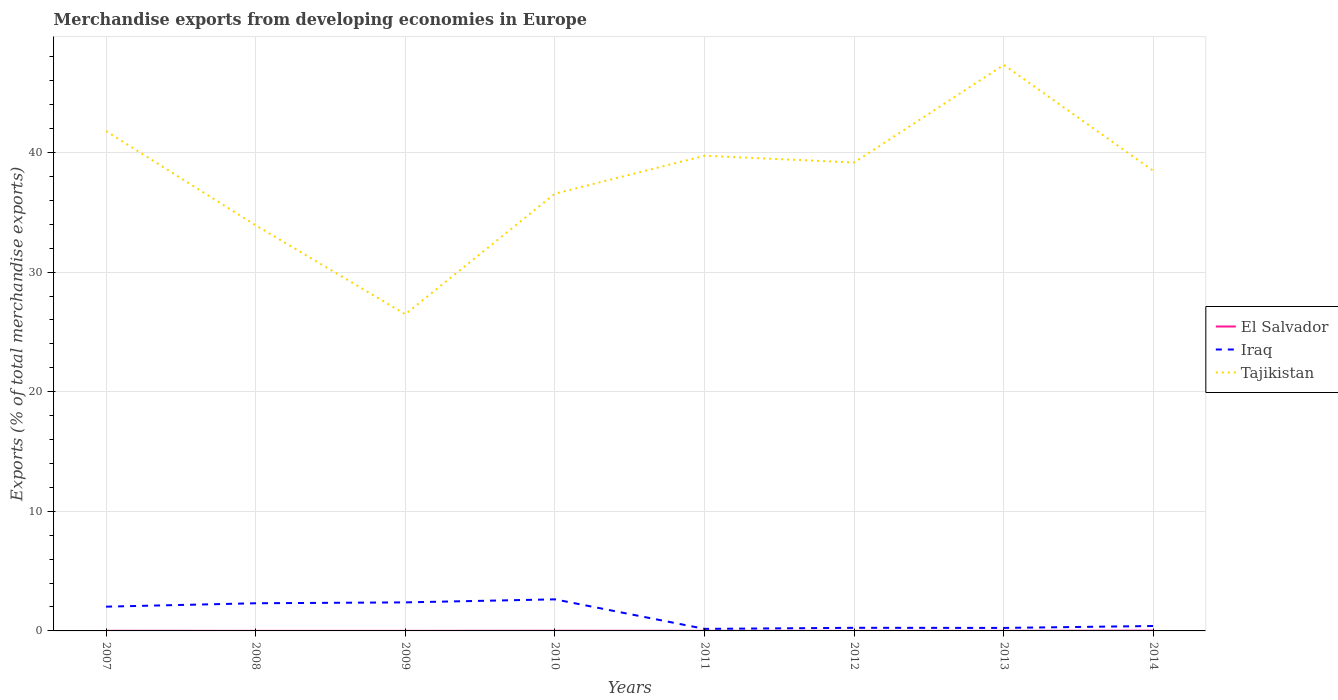How many different coloured lines are there?
Offer a very short reply. 3. Does the line corresponding to El Salvador intersect with the line corresponding to Iraq?
Make the answer very short. No. Is the number of lines equal to the number of legend labels?
Offer a very short reply. Yes. Across all years, what is the maximum percentage of total merchandise exports in Tajikistan?
Your response must be concise. 26.48. In which year was the percentage of total merchandise exports in El Salvador maximum?
Offer a terse response. 2012. What is the total percentage of total merchandise exports in Iraq in the graph?
Ensure brevity in your answer.  -0.07. What is the difference between the highest and the second highest percentage of total merchandise exports in Tajikistan?
Make the answer very short. 20.85. How many lines are there?
Keep it short and to the point. 3. How many years are there in the graph?
Your answer should be compact. 8. Are the values on the major ticks of Y-axis written in scientific E-notation?
Offer a very short reply. No. Does the graph contain grids?
Your response must be concise. Yes. What is the title of the graph?
Ensure brevity in your answer.  Merchandise exports from developing economies in Europe. What is the label or title of the Y-axis?
Your answer should be compact. Exports (% of total merchandise exports). What is the Exports (% of total merchandise exports) of El Salvador in 2007?
Your answer should be very brief. 0.01. What is the Exports (% of total merchandise exports) in Iraq in 2007?
Provide a succinct answer. 2.03. What is the Exports (% of total merchandise exports) in Tajikistan in 2007?
Your answer should be very brief. 41.79. What is the Exports (% of total merchandise exports) in El Salvador in 2008?
Offer a terse response. 0. What is the Exports (% of total merchandise exports) of Iraq in 2008?
Ensure brevity in your answer.  2.31. What is the Exports (% of total merchandise exports) of Tajikistan in 2008?
Your answer should be compact. 33.91. What is the Exports (% of total merchandise exports) of El Salvador in 2009?
Ensure brevity in your answer.  0. What is the Exports (% of total merchandise exports) in Iraq in 2009?
Offer a very short reply. 2.39. What is the Exports (% of total merchandise exports) in Tajikistan in 2009?
Keep it short and to the point. 26.48. What is the Exports (% of total merchandise exports) in El Salvador in 2010?
Your answer should be very brief. 0.01. What is the Exports (% of total merchandise exports) in Iraq in 2010?
Provide a short and direct response. 2.64. What is the Exports (% of total merchandise exports) in Tajikistan in 2010?
Offer a very short reply. 36.56. What is the Exports (% of total merchandise exports) in El Salvador in 2011?
Your answer should be compact. 0.01. What is the Exports (% of total merchandise exports) in Iraq in 2011?
Your response must be concise. 0.17. What is the Exports (% of total merchandise exports) of Tajikistan in 2011?
Ensure brevity in your answer.  39.73. What is the Exports (% of total merchandise exports) in El Salvador in 2012?
Offer a terse response. 0. What is the Exports (% of total merchandise exports) in Iraq in 2012?
Ensure brevity in your answer.  0.26. What is the Exports (% of total merchandise exports) in Tajikistan in 2012?
Provide a short and direct response. 39.16. What is the Exports (% of total merchandise exports) in El Salvador in 2013?
Offer a very short reply. 0. What is the Exports (% of total merchandise exports) in Iraq in 2013?
Keep it short and to the point. 0.25. What is the Exports (% of total merchandise exports) in Tajikistan in 2013?
Offer a terse response. 47.32. What is the Exports (% of total merchandise exports) of El Salvador in 2014?
Provide a succinct answer. 0.02. What is the Exports (% of total merchandise exports) in Iraq in 2014?
Make the answer very short. 0.41. What is the Exports (% of total merchandise exports) in Tajikistan in 2014?
Keep it short and to the point. 38.46. Across all years, what is the maximum Exports (% of total merchandise exports) in El Salvador?
Offer a terse response. 0.02. Across all years, what is the maximum Exports (% of total merchandise exports) in Iraq?
Provide a short and direct response. 2.64. Across all years, what is the maximum Exports (% of total merchandise exports) in Tajikistan?
Your answer should be compact. 47.32. Across all years, what is the minimum Exports (% of total merchandise exports) of El Salvador?
Offer a terse response. 0. Across all years, what is the minimum Exports (% of total merchandise exports) of Iraq?
Your answer should be compact. 0.17. Across all years, what is the minimum Exports (% of total merchandise exports) in Tajikistan?
Ensure brevity in your answer.  26.48. What is the total Exports (% of total merchandise exports) of El Salvador in the graph?
Provide a short and direct response. 0.07. What is the total Exports (% of total merchandise exports) of Iraq in the graph?
Ensure brevity in your answer.  10.46. What is the total Exports (% of total merchandise exports) of Tajikistan in the graph?
Provide a succinct answer. 303.41. What is the difference between the Exports (% of total merchandise exports) of El Salvador in 2007 and that in 2008?
Keep it short and to the point. 0. What is the difference between the Exports (% of total merchandise exports) in Iraq in 2007 and that in 2008?
Offer a terse response. -0.28. What is the difference between the Exports (% of total merchandise exports) of Tajikistan in 2007 and that in 2008?
Your response must be concise. 7.88. What is the difference between the Exports (% of total merchandise exports) in El Salvador in 2007 and that in 2009?
Your answer should be compact. 0. What is the difference between the Exports (% of total merchandise exports) of Iraq in 2007 and that in 2009?
Ensure brevity in your answer.  -0.36. What is the difference between the Exports (% of total merchandise exports) in Tajikistan in 2007 and that in 2009?
Provide a succinct answer. 15.31. What is the difference between the Exports (% of total merchandise exports) of El Salvador in 2007 and that in 2010?
Your answer should be very brief. -0. What is the difference between the Exports (% of total merchandise exports) of Iraq in 2007 and that in 2010?
Ensure brevity in your answer.  -0.61. What is the difference between the Exports (% of total merchandise exports) in Tajikistan in 2007 and that in 2010?
Your answer should be very brief. 5.23. What is the difference between the Exports (% of total merchandise exports) in El Salvador in 2007 and that in 2011?
Offer a terse response. 0. What is the difference between the Exports (% of total merchandise exports) in Iraq in 2007 and that in 2011?
Your answer should be very brief. 1.86. What is the difference between the Exports (% of total merchandise exports) in Tajikistan in 2007 and that in 2011?
Offer a terse response. 2.06. What is the difference between the Exports (% of total merchandise exports) of El Salvador in 2007 and that in 2012?
Your answer should be very brief. 0.01. What is the difference between the Exports (% of total merchandise exports) of Iraq in 2007 and that in 2012?
Provide a short and direct response. 1.77. What is the difference between the Exports (% of total merchandise exports) of Tajikistan in 2007 and that in 2012?
Ensure brevity in your answer.  2.63. What is the difference between the Exports (% of total merchandise exports) in El Salvador in 2007 and that in 2013?
Provide a succinct answer. 0. What is the difference between the Exports (% of total merchandise exports) of Iraq in 2007 and that in 2013?
Provide a short and direct response. 1.78. What is the difference between the Exports (% of total merchandise exports) in Tajikistan in 2007 and that in 2013?
Offer a very short reply. -5.54. What is the difference between the Exports (% of total merchandise exports) of El Salvador in 2007 and that in 2014?
Offer a terse response. -0.01. What is the difference between the Exports (% of total merchandise exports) in Iraq in 2007 and that in 2014?
Ensure brevity in your answer.  1.62. What is the difference between the Exports (% of total merchandise exports) of Tajikistan in 2007 and that in 2014?
Keep it short and to the point. 3.33. What is the difference between the Exports (% of total merchandise exports) of El Salvador in 2008 and that in 2009?
Your response must be concise. 0. What is the difference between the Exports (% of total merchandise exports) of Iraq in 2008 and that in 2009?
Offer a very short reply. -0.07. What is the difference between the Exports (% of total merchandise exports) in Tajikistan in 2008 and that in 2009?
Offer a terse response. 7.44. What is the difference between the Exports (% of total merchandise exports) of El Salvador in 2008 and that in 2010?
Keep it short and to the point. -0.01. What is the difference between the Exports (% of total merchandise exports) of Iraq in 2008 and that in 2010?
Ensure brevity in your answer.  -0.33. What is the difference between the Exports (% of total merchandise exports) of Tajikistan in 2008 and that in 2010?
Your answer should be compact. -2.64. What is the difference between the Exports (% of total merchandise exports) in El Salvador in 2008 and that in 2011?
Offer a terse response. -0. What is the difference between the Exports (% of total merchandise exports) in Iraq in 2008 and that in 2011?
Your response must be concise. 2.14. What is the difference between the Exports (% of total merchandise exports) of Tajikistan in 2008 and that in 2011?
Offer a terse response. -5.82. What is the difference between the Exports (% of total merchandise exports) in El Salvador in 2008 and that in 2012?
Provide a succinct answer. 0. What is the difference between the Exports (% of total merchandise exports) of Iraq in 2008 and that in 2012?
Give a very brief answer. 2.05. What is the difference between the Exports (% of total merchandise exports) of Tajikistan in 2008 and that in 2012?
Provide a succinct answer. -5.25. What is the difference between the Exports (% of total merchandise exports) in El Salvador in 2008 and that in 2013?
Provide a short and direct response. 0. What is the difference between the Exports (% of total merchandise exports) of Iraq in 2008 and that in 2013?
Your answer should be compact. 2.06. What is the difference between the Exports (% of total merchandise exports) of Tajikistan in 2008 and that in 2013?
Offer a terse response. -13.41. What is the difference between the Exports (% of total merchandise exports) of El Salvador in 2008 and that in 2014?
Offer a terse response. -0.02. What is the difference between the Exports (% of total merchandise exports) in Iraq in 2008 and that in 2014?
Your response must be concise. 1.9. What is the difference between the Exports (% of total merchandise exports) of Tajikistan in 2008 and that in 2014?
Offer a terse response. -4.55. What is the difference between the Exports (% of total merchandise exports) in El Salvador in 2009 and that in 2010?
Offer a terse response. -0.01. What is the difference between the Exports (% of total merchandise exports) in Iraq in 2009 and that in 2010?
Your answer should be compact. -0.25. What is the difference between the Exports (% of total merchandise exports) of Tajikistan in 2009 and that in 2010?
Your response must be concise. -10.08. What is the difference between the Exports (% of total merchandise exports) of El Salvador in 2009 and that in 2011?
Make the answer very short. -0. What is the difference between the Exports (% of total merchandise exports) in Iraq in 2009 and that in 2011?
Your response must be concise. 2.22. What is the difference between the Exports (% of total merchandise exports) of Tajikistan in 2009 and that in 2011?
Your answer should be compact. -13.25. What is the difference between the Exports (% of total merchandise exports) of El Salvador in 2009 and that in 2012?
Give a very brief answer. 0. What is the difference between the Exports (% of total merchandise exports) in Iraq in 2009 and that in 2012?
Keep it short and to the point. 2.13. What is the difference between the Exports (% of total merchandise exports) in Tajikistan in 2009 and that in 2012?
Ensure brevity in your answer.  -12.69. What is the difference between the Exports (% of total merchandise exports) in Iraq in 2009 and that in 2013?
Your answer should be very brief. 2.13. What is the difference between the Exports (% of total merchandise exports) in Tajikistan in 2009 and that in 2013?
Ensure brevity in your answer.  -20.85. What is the difference between the Exports (% of total merchandise exports) in El Salvador in 2009 and that in 2014?
Ensure brevity in your answer.  -0.02. What is the difference between the Exports (% of total merchandise exports) in Iraq in 2009 and that in 2014?
Keep it short and to the point. 1.97. What is the difference between the Exports (% of total merchandise exports) of Tajikistan in 2009 and that in 2014?
Your answer should be very brief. -11.98. What is the difference between the Exports (% of total merchandise exports) in El Salvador in 2010 and that in 2011?
Your answer should be very brief. 0. What is the difference between the Exports (% of total merchandise exports) of Iraq in 2010 and that in 2011?
Ensure brevity in your answer.  2.47. What is the difference between the Exports (% of total merchandise exports) of Tajikistan in 2010 and that in 2011?
Provide a short and direct response. -3.17. What is the difference between the Exports (% of total merchandise exports) of El Salvador in 2010 and that in 2012?
Offer a very short reply. 0.01. What is the difference between the Exports (% of total merchandise exports) of Iraq in 2010 and that in 2012?
Your answer should be compact. 2.38. What is the difference between the Exports (% of total merchandise exports) in Tajikistan in 2010 and that in 2012?
Ensure brevity in your answer.  -2.61. What is the difference between the Exports (% of total merchandise exports) of El Salvador in 2010 and that in 2013?
Your answer should be very brief. 0.01. What is the difference between the Exports (% of total merchandise exports) of Iraq in 2010 and that in 2013?
Your answer should be very brief. 2.39. What is the difference between the Exports (% of total merchandise exports) in Tajikistan in 2010 and that in 2013?
Keep it short and to the point. -10.77. What is the difference between the Exports (% of total merchandise exports) in El Salvador in 2010 and that in 2014?
Provide a short and direct response. -0.01. What is the difference between the Exports (% of total merchandise exports) of Iraq in 2010 and that in 2014?
Ensure brevity in your answer.  2.23. What is the difference between the Exports (% of total merchandise exports) of Tajikistan in 2010 and that in 2014?
Offer a terse response. -1.9. What is the difference between the Exports (% of total merchandise exports) in El Salvador in 2011 and that in 2012?
Provide a succinct answer. 0. What is the difference between the Exports (% of total merchandise exports) of Iraq in 2011 and that in 2012?
Your response must be concise. -0.09. What is the difference between the Exports (% of total merchandise exports) in Tajikistan in 2011 and that in 2012?
Make the answer very short. 0.56. What is the difference between the Exports (% of total merchandise exports) in El Salvador in 2011 and that in 2013?
Provide a short and direct response. 0. What is the difference between the Exports (% of total merchandise exports) in Iraq in 2011 and that in 2013?
Offer a terse response. -0.08. What is the difference between the Exports (% of total merchandise exports) in Tajikistan in 2011 and that in 2013?
Ensure brevity in your answer.  -7.6. What is the difference between the Exports (% of total merchandise exports) of El Salvador in 2011 and that in 2014?
Offer a terse response. -0.02. What is the difference between the Exports (% of total merchandise exports) of Iraq in 2011 and that in 2014?
Your answer should be very brief. -0.24. What is the difference between the Exports (% of total merchandise exports) in Tajikistan in 2011 and that in 2014?
Ensure brevity in your answer.  1.27. What is the difference between the Exports (% of total merchandise exports) of El Salvador in 2012 and that in 2013?
Provide a short and direct response. -0. What is the difference between the Exports (% of total merchandise exports) in Iraq in 2012 and that in 2013?
Offer a very short reply. 0.01. What is the difference between the Exports (% of total merchandise exports) of Tajikistan in 2012 and that in 2013?
Your response must be concise. -8.16. What is the difference between the Exports (% of total merchandise exports) in El Salvador in 2012 and that in 2014?
Give a very brief answer. -0.02. What is the difference between the Exports (% of total merchandise exports) of Iraq in 2012 and that in 2014?
Provide a succinct answer. -0.15. What is the difference between the Exports (% of total merchandise exports) in Tajikistan in 2012 and that in 2014?
Offer a terse response. 0.7. What is the difference between the Exports (% of total merchandise exports) of El Salvador in 2013 and that in 2014?
Provide a short and direct response. -0.02. What is the difference between the Exports (% of total merchandise exports) of Iraq in 2013 and that in 2014?
Ensure brevity in your answer.  -0.16. What is the difference between the Exports (% of total merchandise exports) of Tajikistan in 2013 and that in 2014?
Your response must be concise. 8.87. What is the difference between the Exports (% of total merchandise exports) in El Salvador in 2007 and the Exports (% of total merchandise exports) in Iraq in 2008?
Provide a short and direct response. -2.3. What is the difference between the Exports (% of total merchandise exports) in El Salvador in 2007 and the Exports (% of total merchandise exports) in Tajikistan in 2008?
Make the answer very short. -33.9. What is the difference between the Exports (% of total merchandise exports) of Iraq in 2007 and the Exports (% of total merchandise exports) of Tajikistan in 2008?
Your answer should be very brief. -31.88. What is the difference between the Exports (% of total merchandise exports) of El Salvador in 2007 and the Exports (% of total merchandise exports) of Iraq in 2009?
Provide a succinct answer. -2.38. What is the difference between the Exports (% of total merchandise exports) in El Salvador in 2007 and the Exports (% of total merchandise exports) in Tajikistan in 2009?
Your answer should be compact. -26.47. What is the difference between the Exports (% of total merchandise exports) of Iraq in 2007 and the Exports (% of total merchandise exports) of Tajikistan in 2009?
Keep it short and to the point. -24.45. What is the difference between the Exports (% of total merchandise exports) of El Salvador in 2007 and the Exports (% of total merchandise exports) of Iraq in 2010?
Offer a terse response. -2.63. What is the difference between the Exports (% of total merchandise exports) in El Salvador in 2007 and the Exports (% of total merchandise exports) in Tajikistan in 2010?
Ensure brevity in your answer.  -36.55. What is the difference between the Exports (% of total merchandise exports) of Iraq in 2007 and the Exports (% of total merchandise exports) of Tajikistan in 2010?
Provide a short and direct response. -34.53. What is the difference between the Exports (% of total merchandise exports) in El Salvador in 2007 and the Exports (% of total merchandise exports) in Iraq in 2011?
Your answer should be very brief. -0.16. What is the difference between the Exports (% of total merchandise exports) in El Salvador in 2007 and the Exports (% of total merchandise exports) in Tajikistan in 2011?
Ensure brevity in your answer.  -39.72. What is the difference between the Exports (% of total merchandise exports) in Iraq in 2007 and the Exports (% of total merchandise exports) in Tajikistan in 2011?
Your answer should be very brief. -37.7. What is the difference between the Exports (% of total merchandise exports) in El Salvador in 2007 and the Exports (% of total merchandise exports) in Iraq in 2012?
Ensure brevity in your answer.  -0.25. What is the difference between the Exports (% of total merchandise exports) in El Salvador in 2007 and the Exports (% of total merchandise exports) in Tajikistan in 2012?
Offer a very short reply. -39.15. What is the difference between the Exports (% of total merchandise exports) in Iraq in 2007 and the Exports (% of total merchandise exports) in Tajikistan in 2012?
Provide a short and direct response. -37.14. What is the difference between the Exports (% of total merchandise exports) in El Salvador in 2007 and the Exports (% of total merchandise exports) in Iraq in 2013?
Give a very brief answer. -0.24. What is the difference between the Exports (% of total merchandise exports) of El Salvador in 2007 and the Exports (% of total merchandise exports) of Tajikistan in 2013?
Keep it short and to the point. -47.32. What is the difference between the Exports (% of total merchandise exports) in Iraq in 2007 and the Exports (% of total merchandise exports) in Tajikistan in 2013?
Provide a short and direct response. -45.3. What is the difference between the Exports (% of total merchandise exports) of El Salvador in 2007 and the Exports (% of total merchandise exports) of Iraq in 2014?
Give a very brief answer. -0.4. What is the difference between the Exports (% of total merchandise exports) in El Salvador in 2007 and the Exports (% of total merchandise exports) in Tajikistan in 2014?
Provide a short and direct response. -38.45. What is the difference between the Exports (% of total merchandise exports) in Iraq in 2007 and the Exports (% of total merchandise exports) in Tajikistan in 2014?
Your response must be concise. -36.43. What is the difference between the Exports (% of total merchandise exports) of El Salvador in 2008 and the Exports (% of total merchandise exports) of Iraq in 2009?
Offer a very short reply. -2.38. What is the difference between the Exports (% of total merchandise exports) in El Salvador in 2008 and the Exports (% of total merchandise exports) in Tajikistan in 2009?
Offer a terse response. -26.47. What is the difference between the Exports (% of total merchandise exports) of Iraq in 2008 and the Exports (% of total merchandise exports) of Tajikistan in 2009?
Provide a succinct answer. -24.16. What is the difference between the Exports (% of total merchandise exports) of El Salvador in 2008 and the Exports (% of total merchandise exports) of Iraq in 2010?
Make the answer very short. -2.64. What is the difference between the Exports (% of total merchandise exports) of El Salvador in 2008 and the Exports (% of total merchandise exports) of Tajikistan in 2010?
Offer a terse response. -36.55. What is the difference between the Exports (% of total merchandise exports) in Iraq in 2008 and the Exports (% of total merchandise exports) in Tajikistan in 2010?
Provide a short and direct response. -34.24. What is the difference between the Exports (% of total merchandise exports) in El Salvador in 2008 and the Exports (% of total merchandise exports) in Iraq in 2011?
Provide a short and direct response. -0.17. What is the difference between the Exports (% of total merchandise exports) in El Salvador in 2008 and the Exports (% of total merchandise exports) in Tajikistan in 2011?
Provide a succinct answer. -39.72. What is the difference between the Exports (% of total merchandise exports) in Iraq in 2008 and the Exports (% of total merchandise exports) in Tajikistan in 2011?
Ensure brevity in your answer.  -37.41. What is the difference between the Exports (% of total merchandise exports) of El Salvador in 2008 and the Exports (% of total merchandise exports) of Iraq in 2012?
Your answer should be very brief. -0.26. What is the difference between the Exports (% of total merchandise exports) of El Salvador in 2008 and the Exports (% of total merchandise exports) of Tajikistan in 2012?
Provide a short and direct response. -39.16. What is the difference between the Exports (% of total merchandise exports) of Iraq in 2008 and the Exports (% of total merchandise exports) of Tajikistan in 2012?
Provide a short and direct response. -36.85. What is the difference between the Exports (% of total merchandise exports) in El Salvador in 2008 and the Exports (% of total merchandise exports) in Iraq in 2013?
Your response must be concise. -0.25. What is the difference between the Exports (% of total merchandise exports) of El Salvador in 2008 and the Exports (% of total merchandise exports) of Tajikistan in 2013?
Provide a short and direct response. -47.32. What is the difference between the Exports (% of total merchandise exports) of Iraq in 2008 and the Exports (% of total merchandise exports) of Tajikistan in 2013?
Your answer should be compact. -45.01. What is the difference between the Exports (% of total merchandise exports) of El Salvador in 2008 and the Exports (% of total merchandise exports) of Iraq in 2014?
Offer a very short reply. -0.41. What is the difference between the Exports (% of total merchandise exports) in El Salvador in 2008 and the Exports (% of total merchandise exports) in Tajikistan in 2014?
Your response must be concise. -38.45. What is the difference between the Exports (% of total merchandise exports) of Iraq in 2008 and the Exports (% of total merchandise exports) of Tajikistan in 2014?
Give a very brief answer. -36.15. What is the difference between the Exports (% of total merchandise exports) of El Salvador in 2009 and the Exports (% of total merchandise exports) of Iraq in 2010?
Offer a very short reply. -2.64. What is the difference between the Exports (% of total merchandise exports) in El Salvador in 2009 and the Exports (% of total merchandise exports) in Tajikistan in 2010?
Ensure brevity in your answer.  -36.55. What is the difference between the Exports (% of total merchandise exports) of Iraq in 2009 and the Exports (% of total merchandise exports) of Tajikistan in 2010?
Offer a terse response. -34.17. What is the difference between the Exports (% of total merchandise exports) in El Salvador in 2009 and the Exports (% of total merchandise exports) in Iraq in 2011?
Keep it short and to the point. -0.17. What is the difference between the Exports (% of total merchandise exports) of El Salvador in 2009 and the Exports (% of total merchandise exports) of Tajikistan in 2011?
Give a very brief answer. -39.72. What is the difference between the Exports (% of total merchandise exports) in Iraq in 2009 and the Exports (% of total merchandise exports) in Tajikistan in 2011?
Keep it short and to the point. -37.34. What is the difference between the Exports (% of total merchandise exports) of El Salvador in 2009 and the Exports (% of total merchandise exports) of Iraq in 2012?
Your response must be concise. -0.26. What is the difference between the Exports (% of total merchandise exports) of El Salvador in 2009 and the Exports (% of total merchandise exports) of Tajikistan in 2012?
Offer a very short reply. -39.16. What is the difference between the Exports (% of total merchandise exports) in Iraq in 2009 and the Exports (% of total merchandise exports) in Tajikistan in 2012?
Your answer should be compact. -36.78. What is the difference between the Exports (% of total merchandise exports) of El Salvador in 2009 and the Exports (% of total merchandise exports) of Iraq in 2013?
Offer a terse response. -0.25. What is the difference between the Exports (% of total merchandise exports) in El Salvador in 2009 and the Exports (% of total merchandise exports) in Tajikistan in 2013?
Ensure brevity in your answer.  -47.32. What is the difference between the Exports (% of total merchandise exports) in Iraq in 2009 and the Exports (% of total merchandise exports) in Tajikistan in 2013?
Keep it short and to the point. -44.94. What is the difference between the Exports (% of total merchandise exports) in El Salvador in 2009 and the Exports (% of total merchandise exports) in Iraq in 2014?
Your response must be concise. -0.41. What is the difference between the Exports (% of total merchandise exports) of El Salvador in 2009 and the Exports (% of total merchandise exports) of Tajikistan in 2014?
Provide a short and direct response. -38.45. What is the difference between the Exports (% of total merchandise exports) of Iraq in 2009 and the Exports (% of total merchandise exports) of Tajikistan in 2014?
Ensure brevity in your answer.  -36.07. What is the difference between the Exports (% of total merchandise exports) in El Salvador in 2010 and the Exports (% of total merchandise exports) in Iraq in 2011?
Your answer should be very brief. -0.16. What is the difference between the Exports (% of total merchandise exports) of El Salvador in 2010 and the Exports (% of total merchandise exports) of Tajikistan in 2011?
Ensure brevity in your answer.  -39.72. What is the difference between the Exports (% of total merchandise exports) in Iraq in 2010 and the Exports (% of total merchandise exports) in Tajikistan in 2011?
Your answer should be compact. -37.09. What is the difference between the Exports (% of total merchandise exports) of El Salvador in 2010 and the Exports (% of total merchandise exports) of Iraq in 2012?
Make the answer very short. -0.25. What is the difference between the Exports (% of total merchandise exports) of El Salvador in 2010 and the Exports (% of total merchandise exports) of Tajikistan in 2012?
Keep it short and to the point. -39.15. What is the difference between the Exports (% of total merchandise exports) in Iraq in 2010 and the Exports (% of total merchandise exports) in Tajikistan in 2012?
Give a very brief answer. -36.52. What is the difference between the Exports (% of total merchandise exports) in El Salvador in 2010 and the Exports (% of total merchandise exports) in Iraq in 2013?
Offer a terse response. -0.24. What is the difference between the Exports (% of total merchandise exports) of El Salvador in 2010 and the Exports (% of total merchandise exports) of Tajikistan in 2013?
Offer a terse response. -47.31. What is the difference between the Exports (% of total merchandise exports) of Iraq in 2010 and the Exports (% of total merchandise exports) of Tajikistan in 2013?
Keep it short and to the point. -44.68. What is the difference between the Exports (% of total merchandise exports) of El Salvador in 2010 and the Exports (% of total merchandise exports) of Iraq in 2014?
Offer a very short reply. -0.4. What is the difference between the Exports (% of total merchandise exports) of El Salvador in 2010 and the Exports (% of total merchandise exports) of Tajikistan in 2014?
Your response must be concise. -38.45. What is the difference between the Exports (% of total merchandise exports) of Iraq in 2010 and the Exports (% of total merchandise exports) of Tajikistan in 2014?
Offer a very short reply. -35.82. What is the difference between the Exports (% of total merchandise exports) of El Salvador in 2011 and the Exports (% of total merchandise exports) of Iraq in 2012?
Your response must be concise. -0.25. What is the difference between the Exports (% of total merchandise exports) of El Salvador in 2011 and the Exports (% of total merchandise exports) of Tajikistan in 2012?
Ensure brevity in your answer.  -39.16. What is the difference between the Exports (% of total merchandise exports) of Iraq in 2011 and the Exports (% of total merchandise exports) of Tajikistan in 2012?
Your answer should be compact. -38.99. What is the difference between the Exports (% of total merchandise exports) of El Salvador in 2011 and the Exports (% of total merchandise exports) of Iraq in 2013?
Provide a short and direct response. -0.25. What is the difference between the Exports (% of total merchandise exports) of El Salvador in 2011 and the Exports (% of total merchandise exports) of Tajikistan in 2013?
Offer a terse response. -47.32. What is the difference between the Exports (% of total merchandise exports) in Iraq in 2011 and the Exports (% of total merchandise exports) in Tajikistan in 2013?
Offer a terse response. -47.15. What is the difference between the Exports (% of total merchandise exports) of El Salvador in 2011 and the Exports (% of total merchandise exports) of Iraq in 2014?
Provide a short and direct response. -0.41. What is the difference between the Exports (% of total merchandise exports) in El Salvador in 2011 and the Exports (% of total merchandise exports) in Tajikistan in 2014?
Your response must be concise. -38.45. What is the difference between the Exports (% of total merchandise exports) of Iraq in 2011 and the Exports (% of total merchandise exports) of Tajikistan in 2014?
Make the answer very short. -38.29. What is the difference between the Exports (% of total merchandise exports) of El Salvador in 2012 and the Exports (% of total merchandise exports) of Iraq in 2013?
Your answer should be compact. -0.25. What is the difference between the Exports (% of total merchandise exports) of El Salvador in 2012 and the Exports (% of total merchandise exports) of Tajikistan in 2013?
Provide a succinct answer. -47.32. What is the difference between the Exports (% of total merchandise exports) in Iraq in 2012 and the Exports (% of total merchandise exports) in Tajikistan in 2013?
Give a very brief answer. -47.06. What is the difference between the Exports (% of total merchandise exports) in El Salvador in 2012 and the Exports (% of total merchandise exports) in Iraq in 2014?
Offer a terse response. -0.41. What is the difference between the Exports (% of total merchandise exports) in El Salvador in 2012 and the Exports (% of total merchandise exports) in Tajikistan in 2014?
Your answer should be very brief. -38.46. What is the difference between the Exports (% of total merchandise exports) of Iraq in 2012 and the Exports (% of total merchandise exports) of Tajikistan in 2014?
Offer a very short reply. -38.2. What is the difference between the Exports (% of total merchandise exports) in El Salvador in 2013 and the Exports (% of total merchandise exports) in Iraq in 2014?
Make the answer very short. -0.41. What is the difference between the Exports (% of total merchandise exports) of El Salvador in 2013 and the Exports (% of total merchandise exports) of Tajikistan in 2014?
Your response must be concise. -38.46. What is the difference between the Exports (% of total merchandise exports) of Iraq in 2013 and the Exports (% of total merchandise exports) of Tajikistan in 2014?
Give a very brief answer. -38.21. What is the average Exports (% of total merchandise exports) of El Salvador per year?
Keep it short and to the point. 0.01. What is the average Exports (% of total merchandise exports) of Iraq per year?
Provide a succinct answer. 1.31. What is the average Exports (% of total merchandise exports) in Tajikistan per year?
Provide a short and direct response. 37.93. In the year 2007, what is the difference between the Exports (% of total merchandise exports) in El Salvador and Exports (% of total merchandise exports) in Iraq?
Make the answer very short. -2.02. In the year 2007, what is the difference between the Exports (% of total merchandise exports) in El Salvador and Exports (% of total merchandise exports) in Tajikistan?
Keep it short and to the point. -41.78. In the year 2007, what is the difference between the Exports (% of total merchandise exports) of Iraq and Exports (% of total merchandise exports) of Tajikistan?
Provide a succinct answer. -39.76. In the year 2008, what is the difference between the Exports (% of total merchandise exports) in El Salvador and Exports (% of total merchandise exports) in Iraq?
Offer a terse response. -2.31. In the year 2008, what is the difference between the Exports (% of total merchandise exports) of El Salvador and Exports (% of total merchandise exports) of Tajikistan?
Your answer should be compact. -33.91. In the year 2008, what is the difference between the Exports (% of total merchandise exports) in Iraq and Exports (% of total merchandise exports) in Tajikistan?
Provide a short and direct response. -31.6. In the year 2009, what is the difference between the Exports (% of total merchandise exports) in El Salvador and Exports (% of total merchandise exports) in Iraq?
Your answer should be very brief. -2.38. In the year 2009, what is the difference between the Exports (% of total merchandise exports) of El Salvador and Exports (% of total merchandise exports) of Tajikistan?
Provide a short and direct response. -26.47. In the year 2009, what is the difference between the Exports (% of total merchandise exports) of Iraq and Exports (% of total merchandise exports) of Tajikistan?
Give a very brief answer. -24.09. In the year 2010, what is the difference between the Exports (% of total merchandise exports) of El Salvador and Exports (% of total merchandise exports) of Iraq?
Your answer should be compact. -2.63. In the year 2010, what is the difference between the Exports (% of total merchandise exports) of El Salvador and Exports (% of total merchandise exports) of Tajikistan?
Keep it short and to the point. -36.55. In the year 2010, what is the difference between the Exports (% of total merchandise exports) in Iraq and Exports (% of total merchandise exports) in Tajikistan?
Ensure brevity in your answer.  -33.91. In the year 2011, what is the difference between the Exports (% of total merchandise exports) of El Salvador and Exports (% of total merchandise exports) of Iraq?
Provide a succinct answer. -0.16. In the year 2011, what is the difference between the Exports (% of total merchandise exports) of El Salvador and Exports (% of total merchandise exports) of Tajikistan?
Make the answer very short. -39.72. In the year 2011, what is the difference between the Exports (% of total merchandise exports) in Iraq and Exports (% of total merchandise exports) in Tajikistan?
Provide a succinct answer. -39.56. In the year 2012, what is the difference between the Exports (% of total merchandise exports) in El Salvador and Exports (% of total merchandise exports) in Iraq?
Make the answer very short. -0.26. In the year 2012, what is the difference between the Exports (% of total merchandise exports) in El Salvador and Exports (% of total merchandise exports) in Tajikistan?
Your response must be concise. -39.16. In the year 2012, what is the difference between the Exports (% of total merchandise exports) in Iraq and Exports (% of total merchandise exports) in Tajikistan?
Your response must be concise. -38.9. In the year 2013, what is the difference between the Exports (% of total merchandise exports) in El Salvador and Exports (% of total merchandise exports) in Iraq?
Ensure brevity in your answer.  -0.25. In the year 2013, what is the difference between the Exports (% of total merchandise exports) in El Salvador and Exports (% of total merchandise exports) in Tajikistan?
Provide a short and direct response. -47.32. In the year 2013, what is the difference between the Exports (% of total merchandise exports) of Iraq and Exports (% of total merchandise exports) of Tajikistan?
Your answer should be compact. -47.07. In the year 2014, what is the difference between the Exports (% of total merchandise exports) of El Salvador and Exports (% of total merchandise exports) of Iraq?
Ensure brevity in your answer.  -0.39. In the year 2014, what is the difference between the Exports (% of total merchandise exports) in El Salvador and Exports (% of total merchandise exports) in Tajikistan?
Your answer should be very brief. -38.44. In the year 2014, what is the difference between the Exports (% of total merchandise exports) in Iraq and Exports (% of total merchandise exports) in Tajikistan?
Keep it short and to the point. -38.05. What is the ratio of the Exports (% of total merchandise exports) in El Salvador in 2007 to that in 2008?
Your answer should be very brief. 1.83. What is the ratio of the Exports (% of total merchandise exports) in Iraq in 2007 to that in 2008?
Give a very brief answer. 0.88. What is the ratio of the Exports (% of total merchandise exports) of Tajikistan in 2007 to that in 2008?
Keep it short and to the point. 1.23. What is the ratio of the Exports (% of total merchandise exports) of El Salvador in 2007 to that in 2009?
Ensure brevity in your answer.  1.9. What is the ratio of the Exports (% of total merchandise exports) of Iraq in 2007 to that in 2009?
Offer a terse response. 0.85. What is the ratio of the Exports (% of total merchandise exports) of Tajikistan in 2007 to that in 2009?
Ensure brevity in your answer.  1.58. What is the ratio of the Exports (% of total merchandise exports) in El Salvador in 2007 to that in 2010?
Your answer should be very brief. 0.91. What is the ratio of the Exports (% of total merchandise exports) of Iraq in 2007 to that in 2010?
Your answer should be very brief. 0.77. What is the ratio of the Exports (% of total merchandise exports) in Tajikistan in 2007 to that in 2010?
Your answer should be very brief. 1.14. What is the ratio of the Exports (% of total merchandise exports) in El Salvador in 2007 to that in 2011?
Keep it short and to the point. 1.48. What is the ratio of the Exports (% of total merchandise exports) in Iraq in 2007 to that in 2011?
Your response must be concise. 11.87. What is the ratio of the Exports (% of total merchandise exports) of Tajikistan in 2007 to that in 2011?
Keep it short and to the point. 1.05. What is the ratio of the Exports (% of total merchandise exports) in El Salvador in 2007 to that in 2012?
Your answer should be very brief. 2.59. What is the ratio of the Exports (% of total merchandise exports) of Iraq in 2007 to that in 2012?
Your answer should be compact. 7.78. What is the ratio of the Exports (% of total merchandise exports) in Tajikistan in 2007 to that in 2012?
Provide a short and direct response. 1.07. What is the ratio of the Exports (% of total merchandise exports) in El Salvador in 2007 to that in 2013?
Ensure brevity in your answer.  2.01. What is the ratio of the Exports (% of total merchandise exports) of Iraq in 2007 to that in 2013?
Offer a terse response. 8.07. What is the ratio of the Exports (% of total merchandise exports) in Tajikistan in 2007 to that in 2013?
Offer a terse response. 0.88. What is the ratio of the Exports (% of total merchandise exports) of El Salvador in 2007 to that in 2014?
Provide a short and direct response. 0.4. What is the ratio of the Exports (% of total merchandise exports) in Iraq in 2007 to that in 2014?
Your answer should be very brief. 4.92. What is the ratio of the Exports (% of total merchandise exports) in Tajikistan in 2007 to that in 2014?
Offer a very short reply. 1.09. What is the ratio of the Exports (% of total merchandise exports) of El Salvador in 2008 to that in 2009?
Keep it short and to the point. 1.04. What is the ratio of the Exports (% of total merchandise exports) in Iraq in 2008 to that in 2009?
Your answer should be very brief. 0.97. What is the ratio of the Exports (% of total merchandise exports) of Tajikistan in 2008 to that in 2009?
Provide a short and direct response. 1.28. What is the ratio of the Exports (% of total merchandise exports) of El Salvador in 2008 to that in 2010?
Offer a very short reply. 0.49. What is the ratio of the Exports (% of total merchandise exports) of Iraq in 2008 to that in 2010?
Your answer should be compact. 0.88. What is the ratio of the Exports (% of total merchandise exports) of Tajikistan in 2008 to that in 2010?
Keep it short and to the point. 0.93. What is the ratio of the Exports (% of total merchandise exports) of El Salvador in 2008 to that in 2011?
Provide a succinct answer. 0.81. What is the ratio of the Exports (% of total merchandise exports) of Iraq in 2008 to that in 2011?
Provide a succinct answer. 13.54. What is the ratio of the Exports (% of total merchandise exports) of Tajikistan in 2008 to that in 2011?
Make the answer very short. 0.85. What is the ratio of the Exports (% of total merchandise exports) of El Salvador in 2008 to that in 2012?
Provide a short and direct response. 1.41. What is the ratio of the Exports (% of total merchandise exports) of Iraq in 2008 to that in 2012?
Your response must be concise. 8.87. What is the ratio of the Exports (% of total merchandise exports) in Tajikistan in 2008 to that in 2012?
Offer a very short reply. 0.87. What is the ratio of the Exports (% of total merchandise exports) of El Salvador in 2008 to that in 2013?
Provide a succinct answer. 1.1. What is the ratio of the Exports (% of total merchandise exports) in Iraq in 2008 to that in 2013?
Offer a terse response. 9.21. What is the ratio of the Exports (% of total merchandise exports) of Tajikistan in 2008 to that in 2013?
Give a very brief answer. 0.72. What is the ratio of the Exports (% of total merchandise exports) in El Salvador in 2008 to that in 2014?
Provide a short and direct response. 0.22. What is the ratio of the Exports (% of total merchandise exports) of Iraq in 2008 to that in 2014?
Provide a succinct answer. 5.62. What is the ratio of the Exports (% of total merchandise exports) in Tajikistan in 2008 to that in 2014?
Keep it short and to the point. 0.88. What is the ratio of the Exports (% of total merchandise exports) in El Salvador in 2009 to that in 2010?
Your answer should be very brief. 0.48. What is the ratio of the Exports (% of total merchandise exports) in Iraq in 2009 to that in 2010?
Give a very brief answer. 0.9. What is the ratio of the Exports (% of total merchandise exports) of Tajikistan in 2009 to that in 2010?
Provide a short and direct response. 0.72. What is the ratio of the Exports (% of total merchandise exports) in El Salvador in 2009 to that in 2011?
Your response must be concise. 0.77. What is the ratio of the Exports (% of total merchandise exports) in Iraq in 2009 to that in 2011?
Provide a short and direct response. 13.96. What is the ratio of the Exports (% of total merchandise exports) of Tajikistan in 2009 to that in 2011?
Your response must be concise. 0.67. What is the ratio of the Exports (% of total merchandise exports) of El Salvador in 2009 to that in 2012?
Ensure brevity in your answer.  1.36. What is the ratio of the Exports (% of total merchandise exports) of Iraq in 2009 to that in 2012?
Your answer should be compact. 9.15. What is the ratio of the Exports (% of total merchandise exports) in Tajikistan in 2009 to that in 2012?
Ensure brevity in your answer.  0.68. What is the ratio of the Exports (% of total merchandise exports) in El Salvador in 2009 to that in 2013?
Provide a short and direct response. 1.05. What is the ratio of the Exports (% of total merchandise exports) in Iraq in 2009 to that in 2013?
Make the answer very short. 9.5. What is the ratio of the Exports (% of total merchandise exports) of Tajikistan in 2009 to that in 2013?
Keep it short and to the point. 0.56. What is the ratio of the Exports (% of total merchandise exports) of El Salvador in 2009 to that in 2014?
Provide a short and direct response. 0.21. What is the ratio of the Exports (% of total merchandise exports) of Iraq in 2009 to that in 2014?
Offer a very short reply. 5.79. What is the ratio of the Exports (% of total merchandise exports) in Tajikistan in 2009 to that in 2014?
Give a very brief answer. 0.69. What is the ratio of the Exports (% of total merchandise exports) of El Salvador in 2010 to that in 2011?
Offer a very short reply. 1.63. What is the ratio of the Exports (% of total merchandise exports) of Iraq in 2010 to that in 2011?
Provide a short and direct response. 15.45. What is the ratio of the Exports (% of total merchandise exports) in Tajikistan in 2010 to that in 2011?
Provide a succinct answer. 0.92. What is the ratio of the Exports (% of total merchandise exports) of El Salvador in 2010 to that in 2012?
Keep it short and to the point. 2.86. What is the ratio of the Exports (% of total merchandise exports) in Iraq in 2010 to that in 2012?
Ensure brevity in your answer.  10.12. What is the ratio of the Exports (% of total merchandise exports) in Tajikistan in 2010 to that in 2012?
Your answer should be compact. 0.93. What is the ratio of the Exports (% of total merchandise exports) of El Salvador in 2010 to that in 2013?
Provide a short and direct response. 2.22. What is the ratio of the Exports (% of total merchandise exports) in Iraq in 2010 to that in 2013?
Keep it short and to the point. 10.51. What is the ratio of the Exports (% of total merchandise exports) of Tajikistan in 2010 to that in 2013?
Offer a very short reply. 0.77. What is the ratio of the Exports (% of total merchandise exports) in El Salvador in 2010 to that in 2014?
Your answer should be compact. 0.44. What is the ratio of the Exports (% of total merchandise exports) in Iraq in 2010 to that in 2014?
Provide a succinct answer. 6.41. What is the ratio of the Exports (% of total merchandise exports) in Tajikistan in 2010 to that in 2014?
Offer a terse response. 0.95. What is the ratio of the Exports (% of total merchandise exports) in El Salvador in 2011 to that in 2012?
Keep it short and to the point. 1.75. What is the ratio of the Exports (% of total merchandise exports) in Iraq in 2011 to that in 2012?
Offer a very short reply. 0.66. What is the ratio of the Exports (% of total merchandise exports) of Tajikistan in 2011 to that in 2012?
Ensure brevity in your answer.  1.01. What is the ratio of the Exports (% of total merchandise exports) of El Salvador in 2011 to that in 2013?
Provide a short and direct response. 1.36. What is the ratio of the Exports (% of total merchandise exports) in Iraq in 2011 to that in 2013?
Provide a short and direct response. 0.68. What is the ratio of the Exports (% of total merchandise exports) in Tajikistan in 2011 to that in 2013?
Ensure brevity in your answer.  0.84. What is the ratio of the Exports (% of total merchandise exports) in El Salvador in 2011 to that in 2014?
Make the answer very short. 0.27. What is the ratio of the Exports (% of total merchandise exports) of Iraq in 2011 to that in 2014?
Offer a very short reply. 0.41. What is the ratio of the Exports (% of total merchandise exports) of Tajikistan in 2011 to that in 2014?
Give a very brief answer. 1.03. What is the ratio of the Exports (% of total merchandise exports) of El Salvador in 2012 to that in 2013?
Your answer should be compact. 0.78. What is the ratio of the Exports (% of total merchandise exports) in Iraq in 2012 to that in 2013?
Provide a short and direct response. 1.04. What is the ratio of the Exports (% of total merchandise exports) of Tajikistan in 2012 to that in 2013?
Your response must be concise. 0.83. What is the ratio of the Exports (% of total merchandise exports) in El Salvador in 2012 to that in 2014?
Offer a terse response. 0.15. What is the ratio of the Exports (% of total merchandise exports) in Iraq in 2012 to that in 2014?
Provide a succinct answer. 0.63. What is the ratio of the Exports (% of total merchandise exports) of Tajikistan in 2012 to that in 2014?
Your response must be concise. 1.02. What is the ratio of the Exports (% of total merchandise exports) in El Salvador in 2013 to that in 2014?
Ensure brevity in your answer.  0.2. What is the ratio of the Exports (% of total merchandise exports) in Iraq in 2013 to that in 2014?
Ensure brevity in your answer.  0.61. What is the ratio of the Exports (% of total merchandise exports) of Tajikistan in 2013 to that in 2014?
Provide a succinct answer. 1.23. What is the difference between the highest and the second highest Exports (% of total merchandise exports) of El Salvador?
Provide a short and direct response. 0.01. What is the difference between the highest and the second highest Exports (% of total merchandise exports) of Iraq?
Ensure brevity in your answer.  0.25. What is the difference between the highest and the second highest Exports (% of total merchandise exports) in Tajikistan?
Your response must be concise. 5.54. What is the difference between the highest and the lowest Exports (% of total merchandise exports) in El Salvador?
Your answer should be very brief. 0.02. What is the difference between the highest and the lowest Exports (% of total merchandise exports) in Iraq?
Your answer should be compact. 2.47. What is the difference between the highest and the lowest Exports (% of total merchandise exports) in Tajikistan?
Make the answer very short. 20.85. 